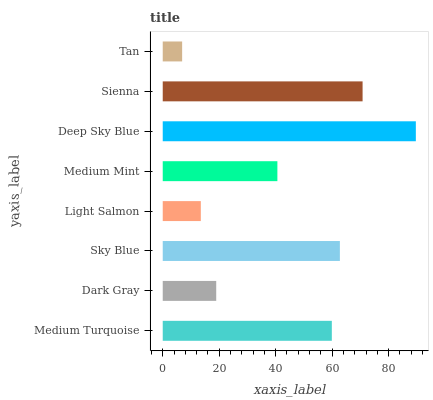Is Tan the minimum?
Answer yes or no. Yes. Is Deep Sky Blue the maximum?
Answer yes or no. Yes. Is Dark Gray the minimum?
Answer yes or no. No. Is Dark Gray the maximum?
Answer yes or no. No. Is Medium Turquoise greater than Dark Gray?
Answer yes or no. Yes. Is Dark Gray less than Medium Turquoise?
Answer yes or no. Yes. Is Dark Gray greater than Medium Turquoise?
Answer yes or no. No. Is Medium Turquoise less than Dark Gray?
Answer yes or no. No. Is Medium Turquoise the high median?
Answer yes or no. Yes. Is Medium Mint the low median?
Answer yes or no. Yes. Is Tan the high median?
Answer yes or no. No. Is Tan the low median?
Answer yes or no. No. 